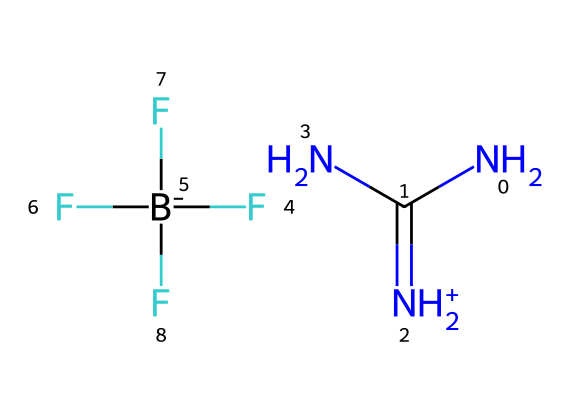What is the cation present in this ionic liquid? The chemical structure includes a guanidinium moiety, represented by the NC(=[NH2+])N part, indicating that guanidinium is the cation.
Answer: guanidinium How many nitrogen atoms are in this compound? The structure shows three nitrogen atoms labeled in the formula, two in the guanidinium and one in the counteranion part of BF4.
Answer: three What type of bonding is indicated by the presence of the nitrogen with a plus charge? The presence of a positively charged nitrogen suggests this nitrogen is involved in coordination bonds, indicating a strong ionic interaction.
Answer: ionic What is the role of the BF4- in this ionic liquid? BF4- acts as an anion that balances the positive charge of the guanidinium cation, essential for maintaining charge neutrality in ionic liquids.
Answer: stabilizing anion How many fluorine atoms are present in the counterion? The SMILES shows a BF4 group, which indicates there are four fluorine atoms in the counterion.
Answer: four In which applications are guanidinium-based ionic liquids typically used? Guanidinium-based ionic liquids are commonly used as solvents and electrolytes in various applications including fertilizers.
Answer: fertilizers What property is primarily affected by the ionic nature of this liquid? The ionic nature gives the liquid low volatility which is a significant property impacting safety and environmental considerations.
Answer: low volatility 